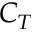Convert formula to latex. <formula><loc_0><loc_0><loc_500><loc_500>C _ { T }</formula> 